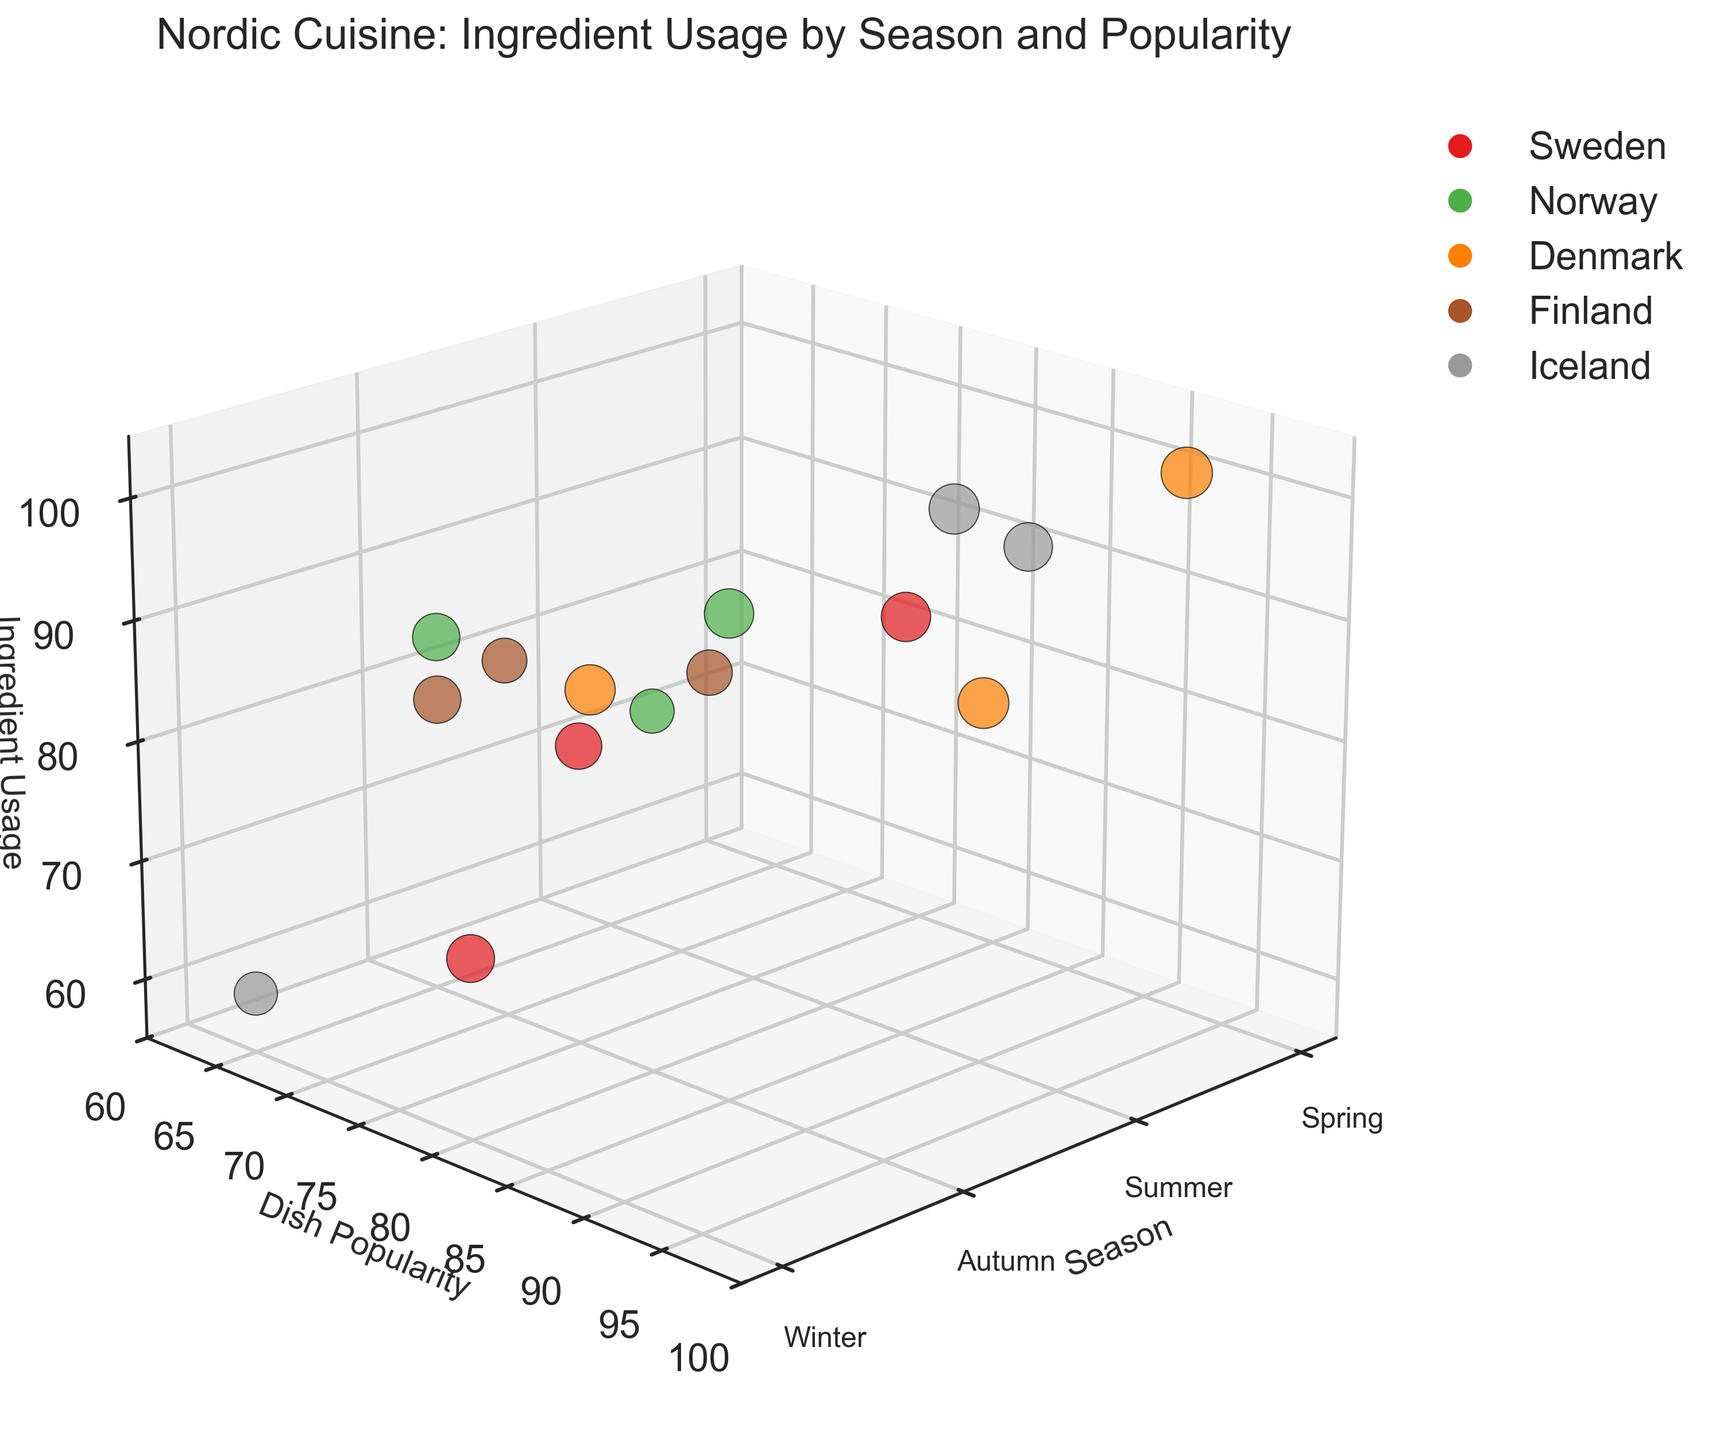What's the title of the figure? The title is displayed at the top of the figure. It reads 'Nordic Cuisine: Ingredient Usage by Season and Popularity'.
Answer: Nordic Cuisine: Ingredient Usage by Season and Popularity Which axis represents the seasons, and what are the labels? The x-axis represents the seasons and is labeled as 'Season'. The labels are Spring, Summer, Autumn, and Winter.
Answer: x-axis, Spring, Summer, Autumn, Winter What color represents dishes from Iceland? Each country is represented by a distinct color in the scatter plot. By observing the legend on the right, we can see which color corresponds to Iceland.
Answer: The color representing Iceland is identified through the legend How many dishes are represented in the Summer season? By locating the points corresponding to Summer on the x-axis and counting them, we can determine the number of dishes for that season.
Answer: There are 5 dishes in Summer Which dish has the highest ingredient usage in Winter? We look for the largest z-value (Ingredient Usage) among points marked for Winter on the x-axis. Each country's color can help identify the dish.
Answer: Fårikål with Lamb (95) What is the average popularity of dishes in Autumn? Find the points corresponding to Autumn on the x-axis and average their y-values (Popularity). The dishes are Lohikeitto (70), Kantarellsoppa (75), and Pinnekjøtt (85).
Answer: (70 + 75 + 85) / 3 = 76.67 Which season has the most variety of ingredient usage? Compare the range of the z-values (Ingredient Usage) for each season by observing the spread on the z-axis.
Answer: Winter Compare the popularity of the most popular dish in Spring versus Winter. Which one is higher? Identify the highest y-value (Popularity) for dishes in Spring and Winter. In Spring, the highest value is 92 (Smørrebrød) and in Winter, it is 88 (Stegt Flæsk).
Answer: Spring, 92 Are there any dishes with the same popularity and different ingredient usage within the same season? Search for points in the same season (same x-value) that share the same y-value but diverge on the z-axis (Ingredient Usage).
Answer: No, there are no such dishes Which dish has the largest bubble size in the Summer season? Bubble size correlates with popularity. Within the Summer points, the largest bubble has the highest y-value. The largest bubble corresponds to Smørrebrød (92).
Answer: Smørrebrød 